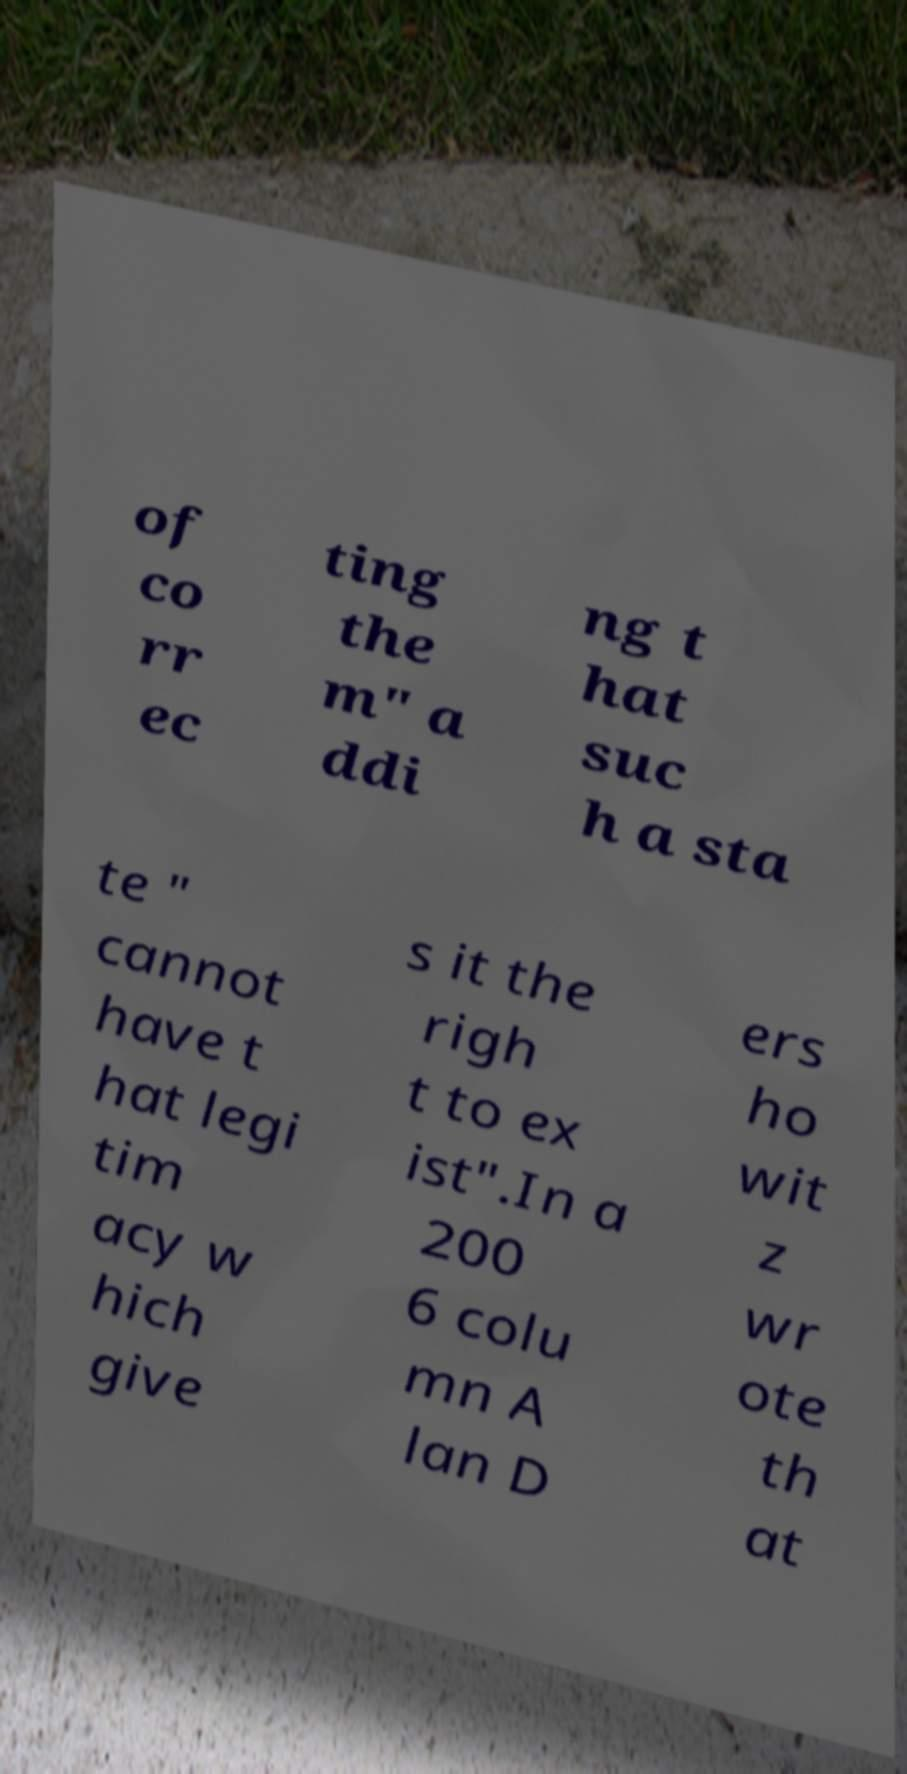Can you accurately transcribe the text from the provided image for me? of co rr ec ting the m" a ddi ng t hat suc h a sta te " cannot have t hat legi tim acy w hich give s it the righ t to ex ist".In a 200 6 colu mn A lan D ers ho wit z wr ote th at 